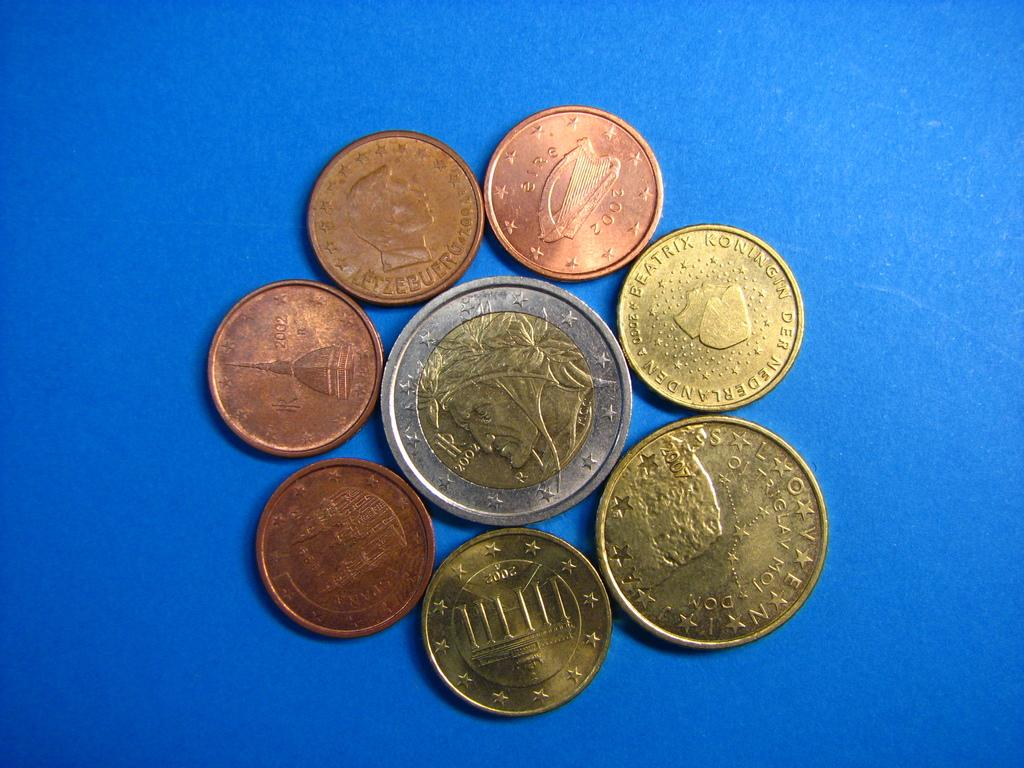<image>
Summarize the visual content of the image. some coins with one that has 2002 on it 